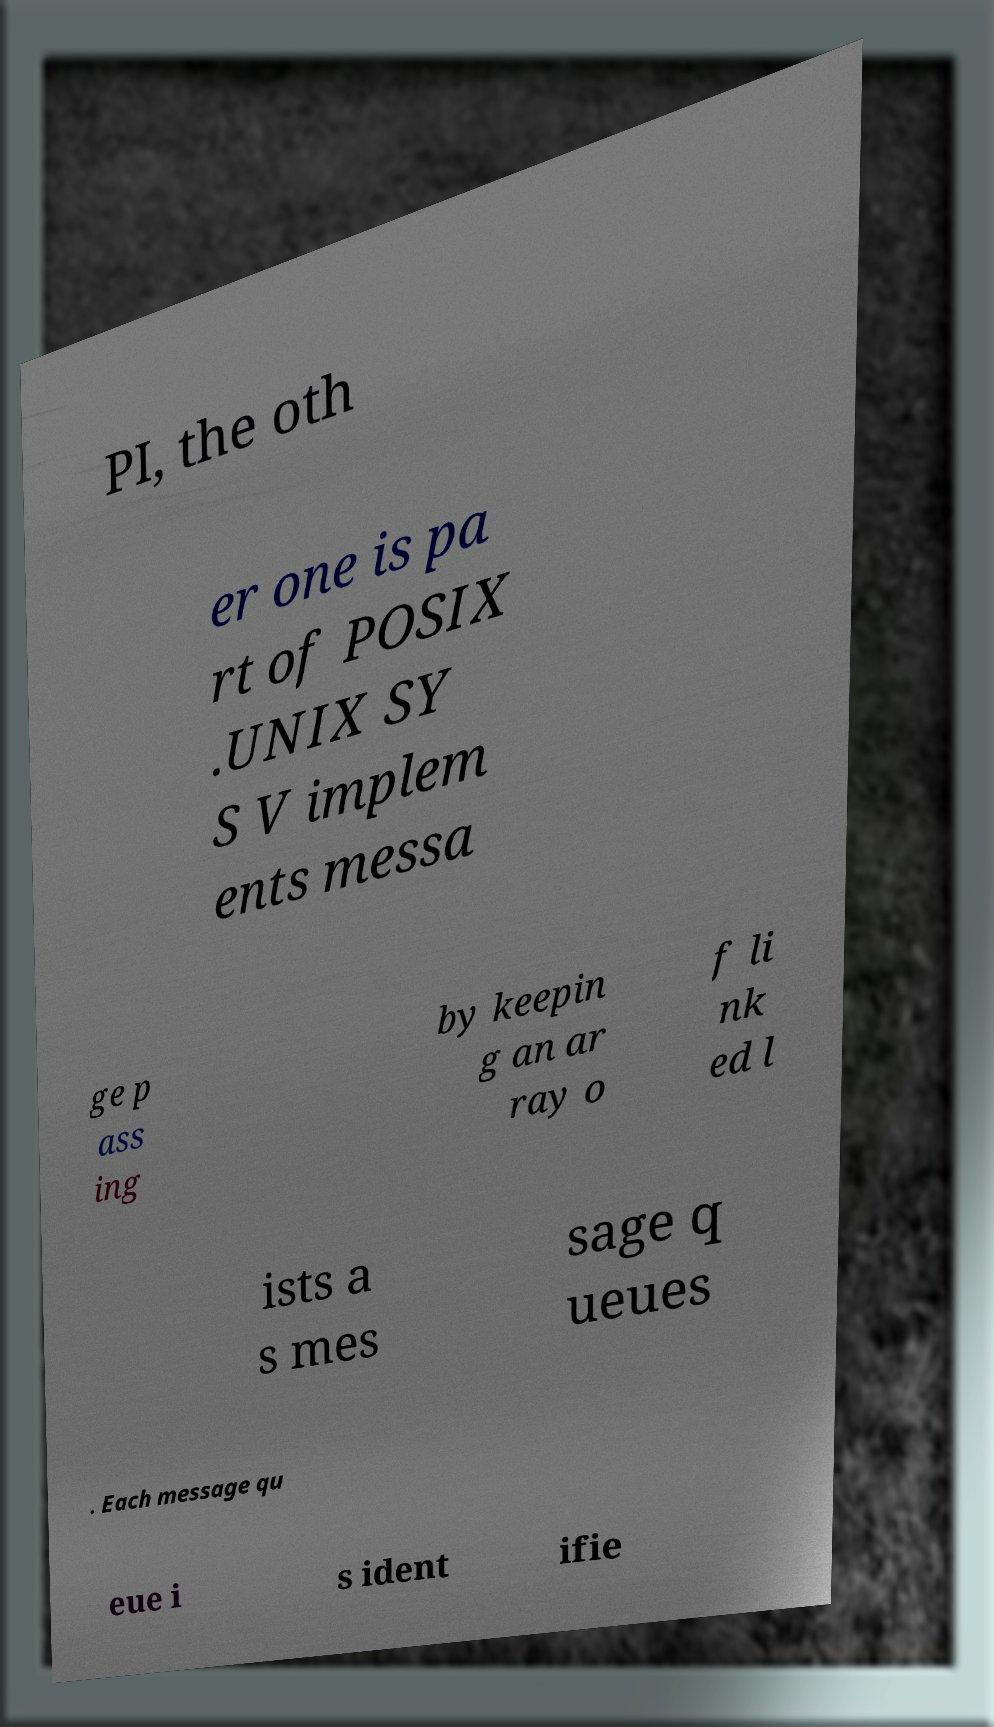Could you extract and type out the text from this image? PI, the oth er one is pa rt of POSIX .UNIX SY S V implem ents messa ge p ass ing by keepin g an ar ray o f li nk ed l ists a s mes sage q ueues . Each message qu eue i s ident ifie 